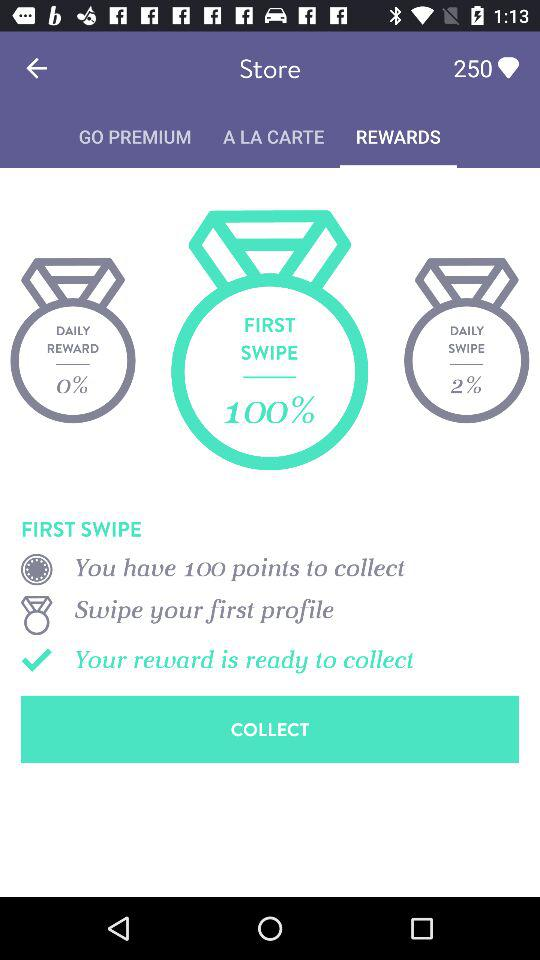How many more points can you earn by signing up with facebook than with a phone number?
Answer the question using a single word or phrase. 250 